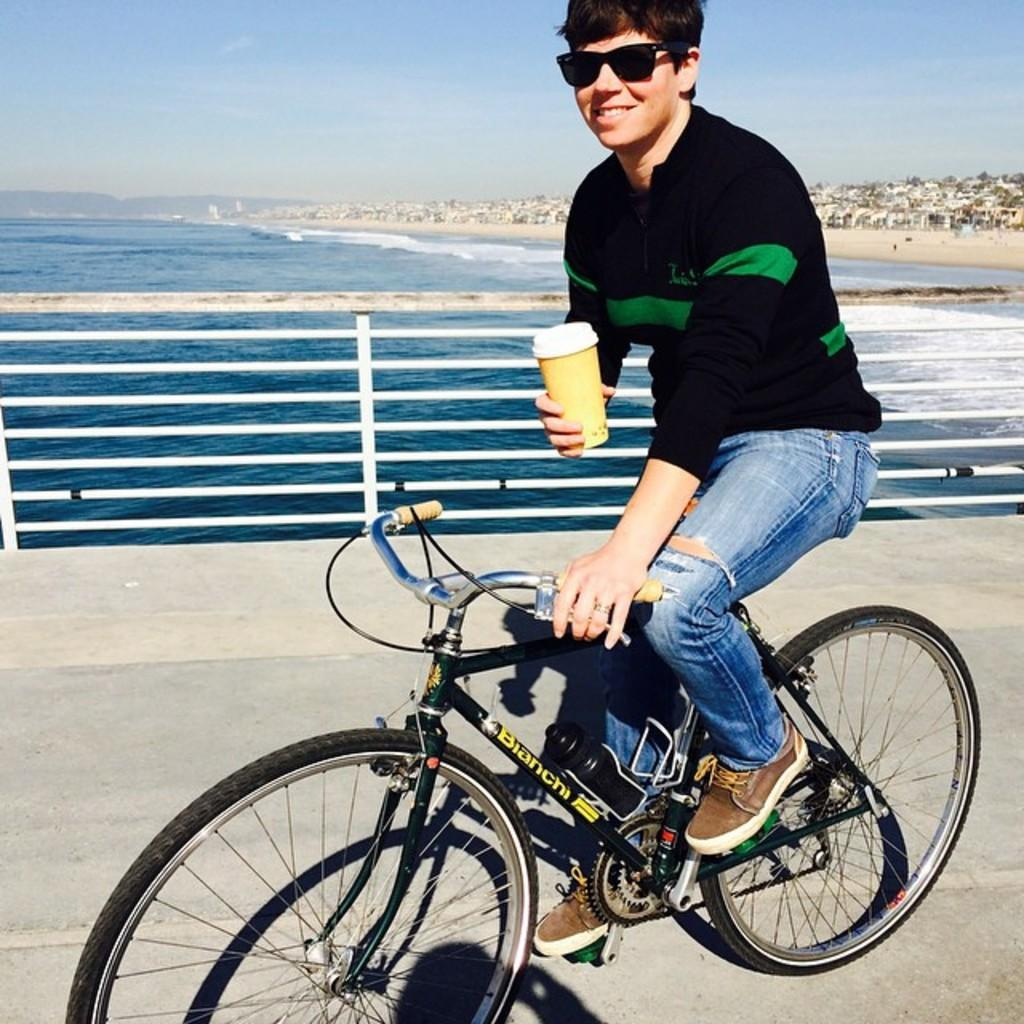What is the man in the image doing? The man is riding a bicycle in the image. What is the man holding while riding the bicycle? The man is holding a cup of coffee in his hand. What type of protective eyewear is the man wearing? The man is wearing goggles. What can be seen in the background of the image? There is a sea present in the background of the image. What is the man leaning on while riding the bicycle? The facts provided do not mention the man leaning on anything while riding the bicycle. What type of power does the man have over the bikes in the image? There is no indication in the image that the man has any power over bikes, as he is simply riding one himself. Is there a servant present in the image to assist the man? There is no servant present in the image; the man is riding the bicycle alone. 